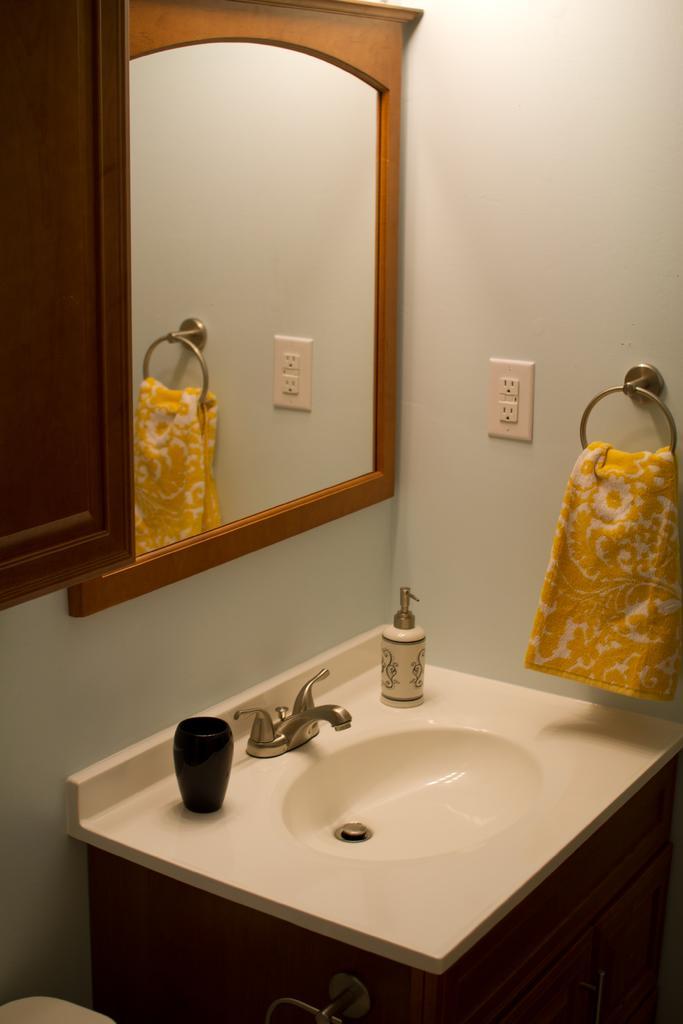Describe this image in one or two sentences. We can see the reflection of a towel, wall, socket and a stand in a mirror. In this picture we can see the wooden cupboard, washbasin, tap , bottle and a black object. At the bottom portion of the picture we can see a stand on the wooden cupboard. 